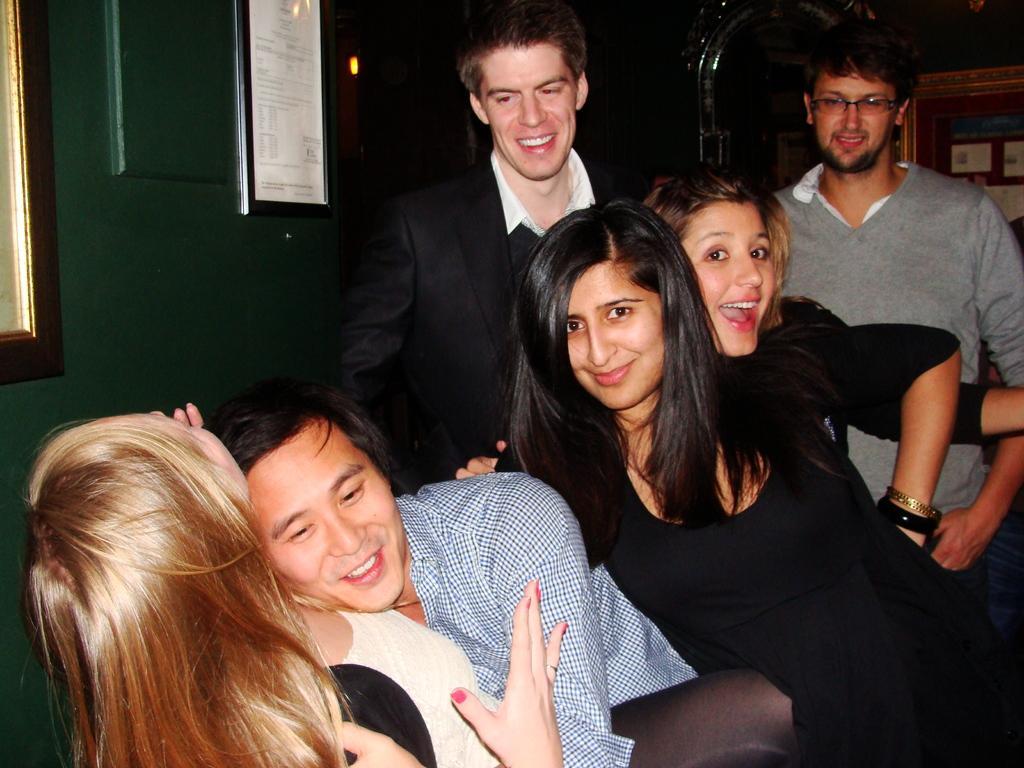Could you give a brief overview of what you see in this image? In this image I can see few people and they are wearing different color dresses. I can see a frame is attached to the green wall and few objects at back. 